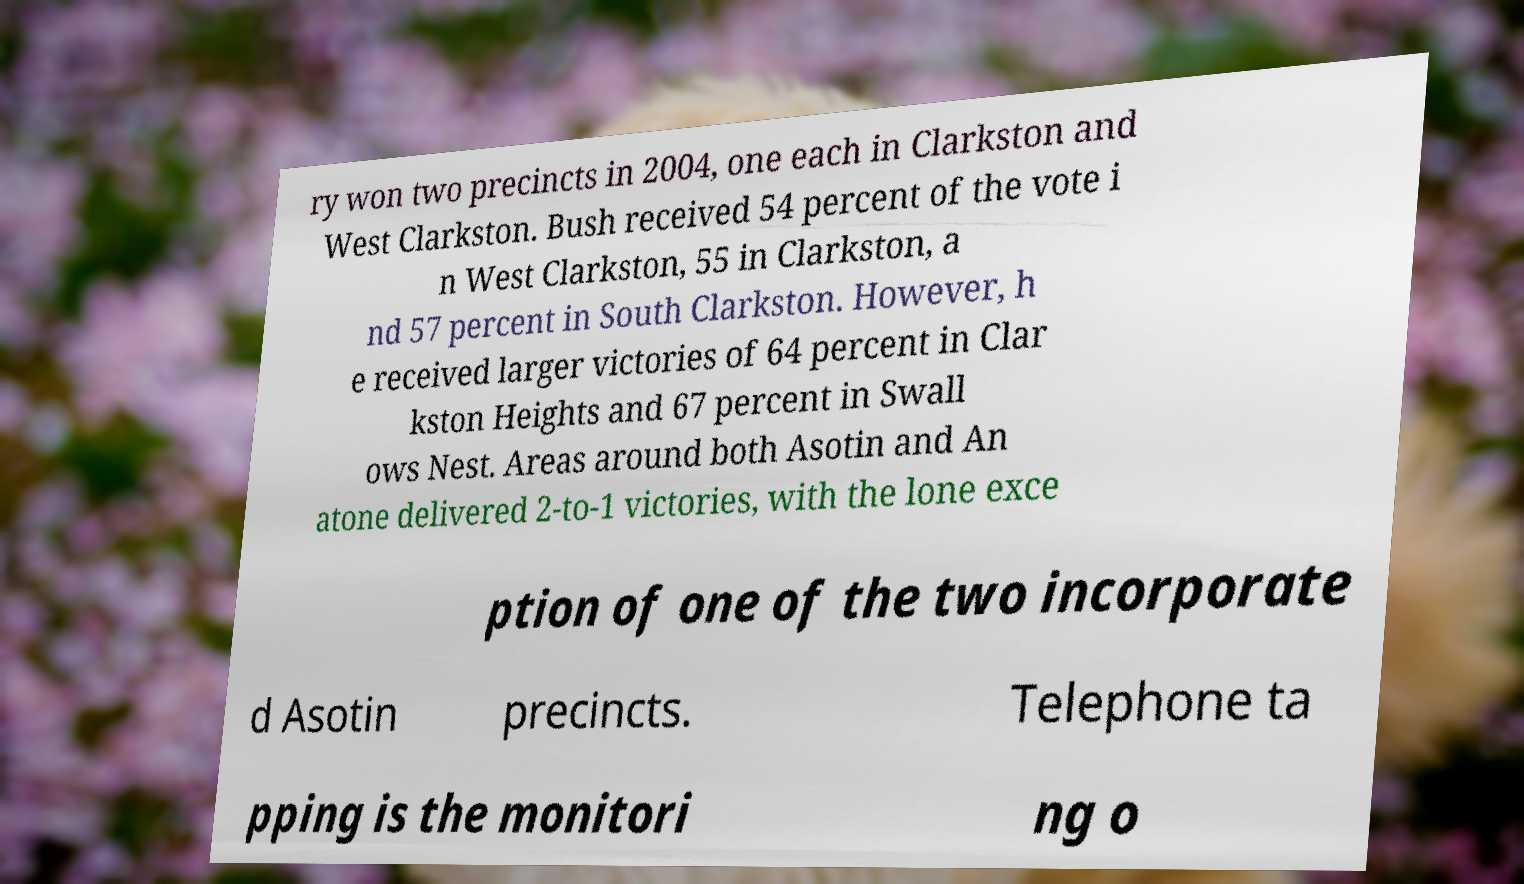Could you extract and type out the text from this image? ry won two precincts in 2004, one each in Clarkston and West Clarkston. Bush received 54 percent of the vote i n West Clarkston, 55 in Clarkston, a nd 57 percent in South Clarkston. However, h e received larger victories of 64 percent in Clar kston Heights and 67 percent in Swall ows Nest. Areas around both Asotin and An atone delivered 2-to-1 victories, with the lone exce ption of one of the two incorporate d Asotin precincts. Telephone ta pping is the monitori ng o 